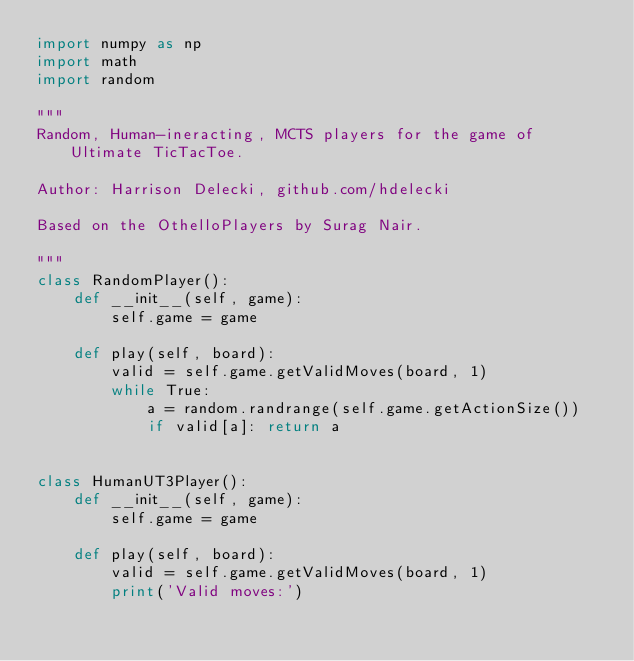<code> <loc_0><loc_0><loc_500><loc_500><_Python_>import numpy as np
import math
import random

"""
Random, Human-ineracting, MCTS players for the game of Ultimate TicTacToe.

Author: Harrison Delecki, github.com/hdelecki

Based on the OthelloPlayers by Surag Nair.

"""
class RandomPlayer():
    def __init__(self, game):
        self.game = game

    def play(self, board):
        valid = self.game.getValidMoves(board, 1)
        while True:
            a = random.randrange(self.game.getActionSize())
            if valid[a]: return a


class HumanUT3Player():
    def __init__(self, game):
        self.game = game

    def play(self, board):
        valid = self.game.getValidMoves(board, 1)
        print('Valid moves:')</code> 